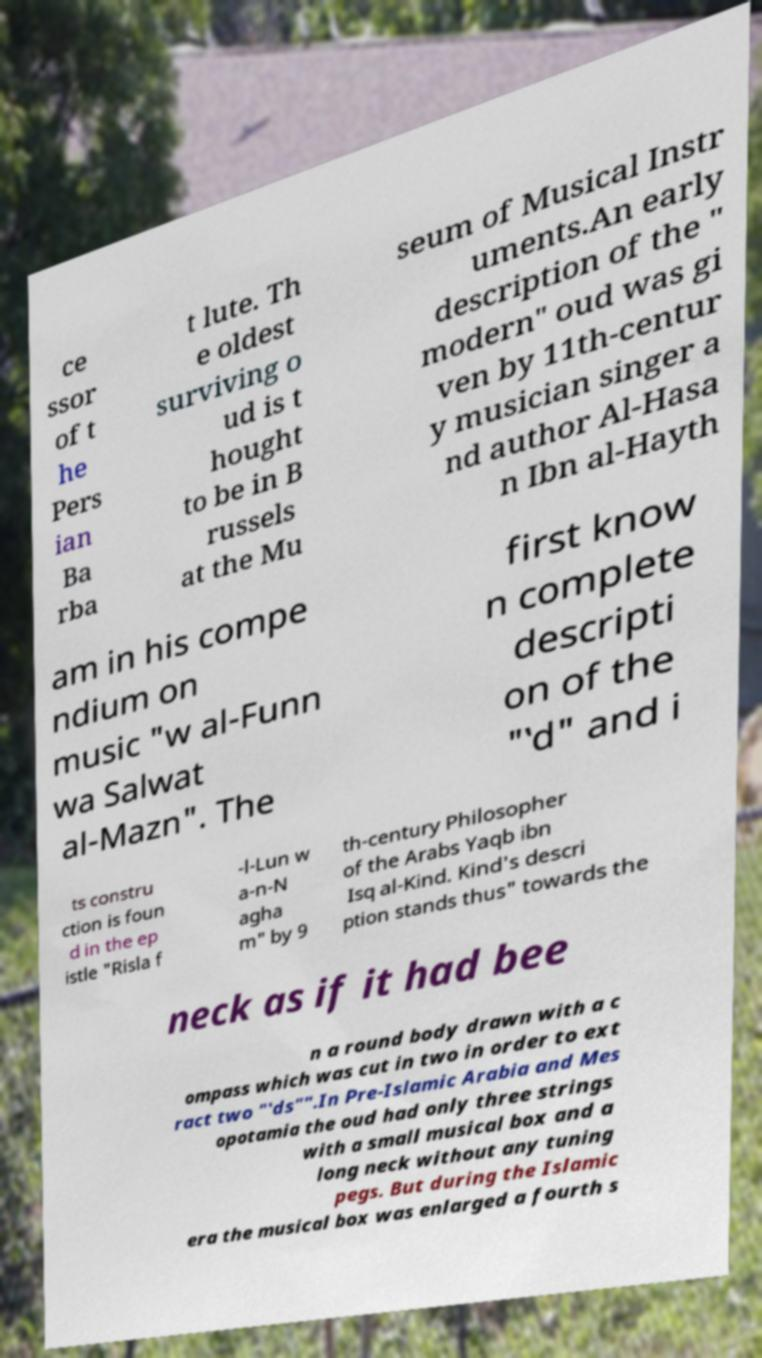Can you read and provide the text displayed in the image?This photo seems to have some interesting text. Can you extract and type it out for me? ce ssor of t he Pers ian Ba rba t lute. Th e oldest surviving o ud is t hought to be in B russels at the Mu seum of Musical Instr uments.An early description of the " modern" oud was gi ven by 11th-centur y musician singer a nd author Al-Hasa n Ibn al-Hayth am in his compe ndium on music "w al-Funn wa Salwat al-Mazn". The first know n complete descripti on of the "‛d" and i ts constru ction is foun d in the ep istle "Risla f -l-Lun w a-n-N agha m" by 9 th-century Philosopher of the Arabs Yaqb ibn Isq al-Kind. Kind's descri ption stands thus" towards the neck as if it had bee n a round body drawn with a c ompass which was cut in two in order to ext ract two "‛ds"".In Pre-Islamic Arabia and Mes opotamia the oud had only three strings with a small musical box and a long neck without any tuning pegs. But during the Islamic era the musical box was enlarged a fourth s 